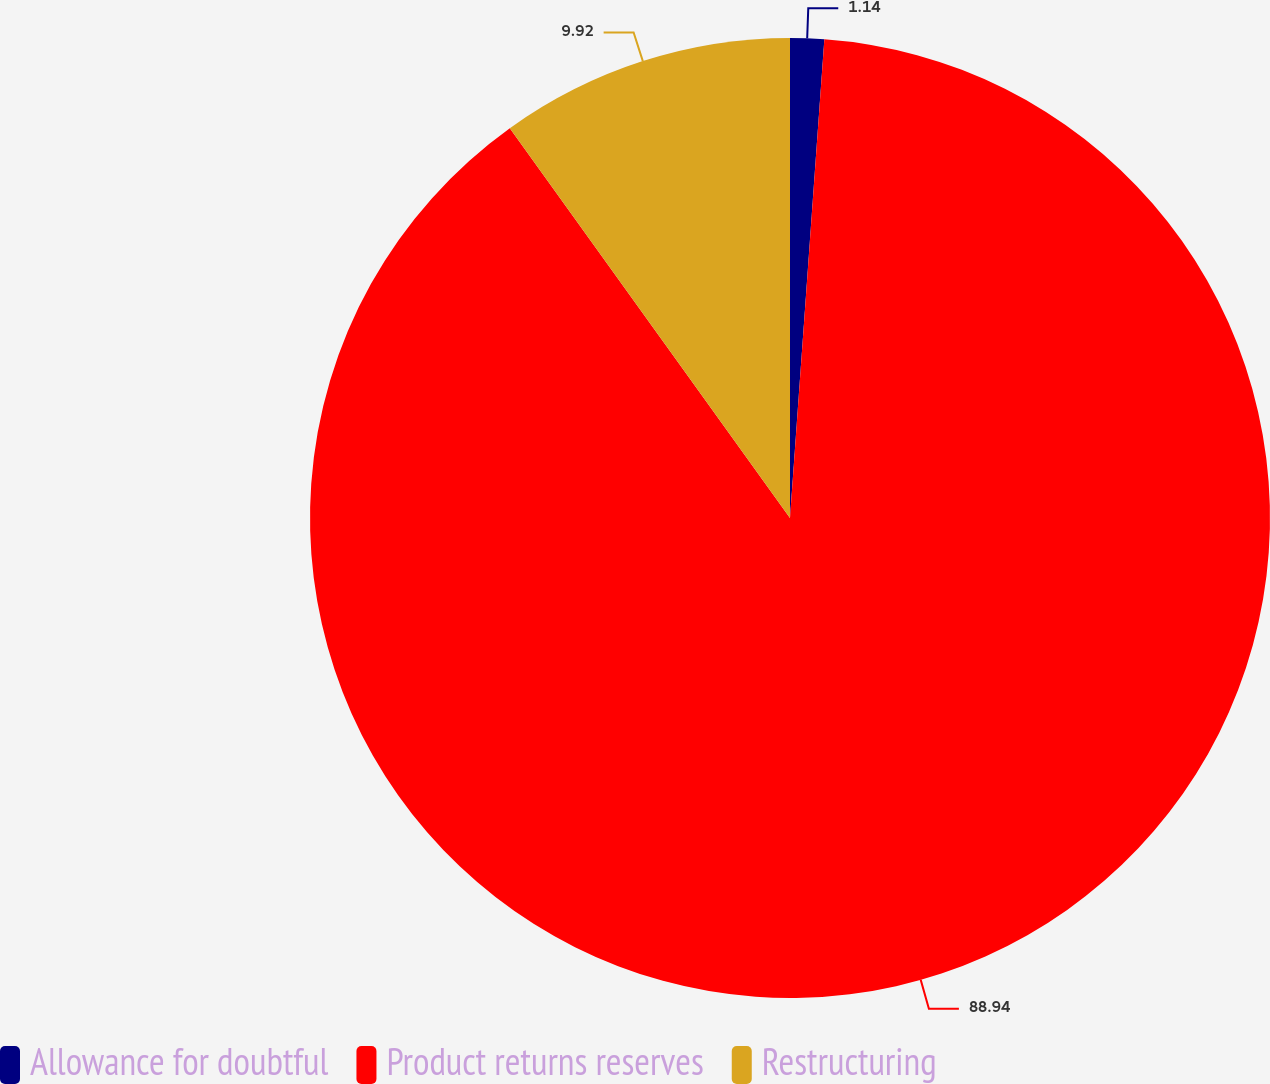<chart> <loc_0><loc_0><loc_500><loc_500><pie_chart><fcel>Allowance for doubtful<fcel>Product returns reserves<fcel>Restructuring<nl><fcel>1.14%<fcel>88.94%<fcel>9.92%<nl></chart> 